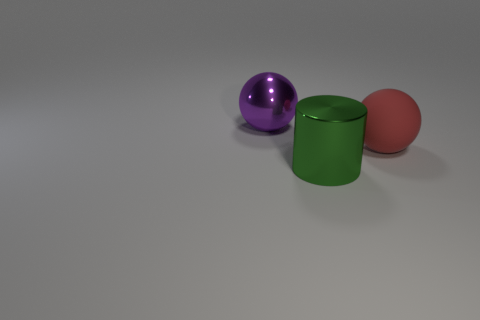Subtract all gray spheres. Subtract all blue blocks. How many spheres are left? 2 Add 2 green cylinders. How many objects exist? 5 Subtract all balls. How many objects are left? 1 Subtract all big shiny cylinders. Subtract all red spheres. How many objects are left? 1 Add 3 metal spheres. How many metal spheres are left? 4 Add 2 large red things. How many large red things exist? 3 Subtract 0 blue cylinders. How many objects are left? 3 